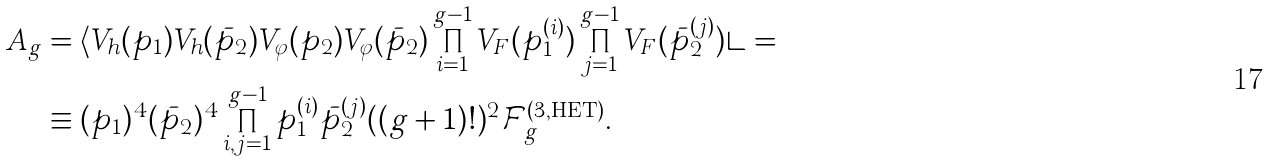Convert formula to latex. <formula><loc_0><loc_0><loc_500><loc_500>A _ { g } & = \langle V _ { h } ( p _ { 1 } ) V _ { h } ( \bar { p } _ { 2 } ) V _ { \varphi } ( p _ { 2 } ) V _ { \varphi } ( \bar { p } _ { 2 } ) \prod _ { i = 1 } ^ { g - 1 } V _ { F } ( p _ { 1 } ^ { ( i ) } ) \prod _ { j = 1 } ^ { g - 1 } V _ { F } ( \bar { p } _ { 2 } ^ { ( j ) } ) \rangle = \\ & \equiv ( p _ { 1 } ) ^ { 4 } ( \bar { p } _ { 2 } ) ^ { 4 } \prod _ { i , j = 1 } ^ { g - 1 } p _ { 1 } ^ { ( i ) } \bar { p } _ { 2 } ^ { ( j ) } ( ( g + 1 ) ! ) ^ { 2 } \mathcal { F } _ { g } ^ { ( 3 , \text {HET} ) } .</formula> 